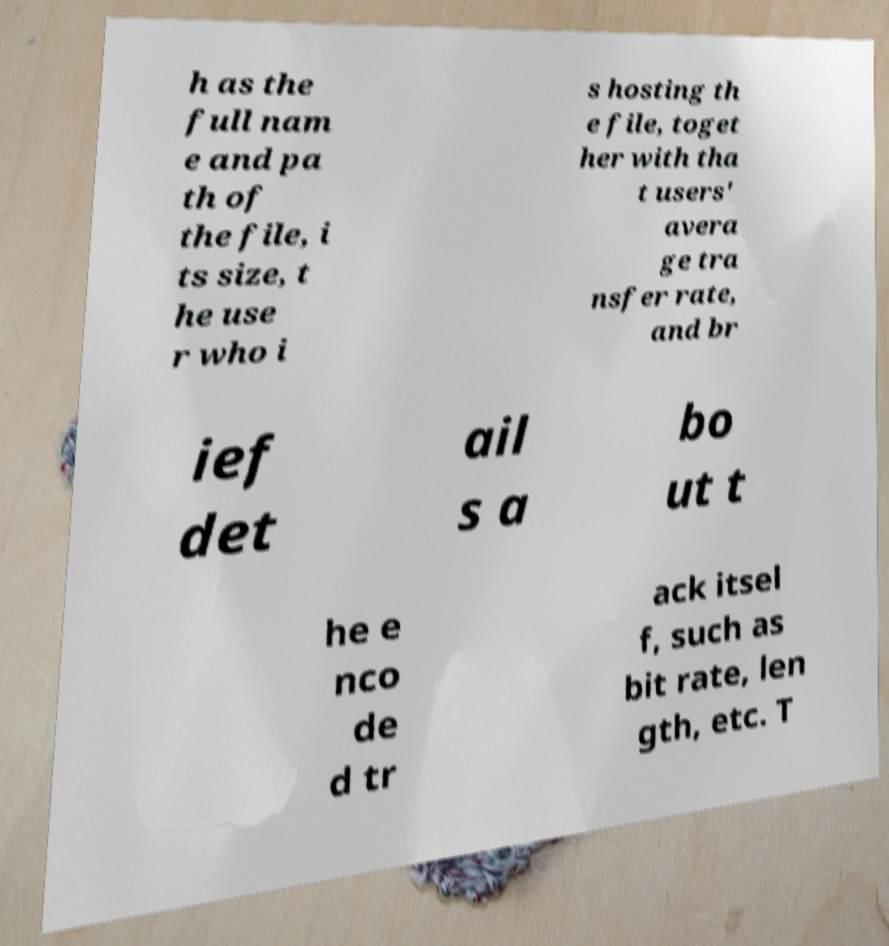For documentation purposes, I need the text within this image transcribed. Could you provide that? h as the full nam e and pa th of the file, i ts size, t he use r who i s hosting th e file, toget her with tha t users' avera ge tra nsfer rate, and br ief det ail s a bo ut t he e nco de d tr ack itsel f, such as bit rate, len gth, etc. T 